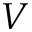<formula> <loc_0><loc_0><loc_500><loc_500>V</formula> 